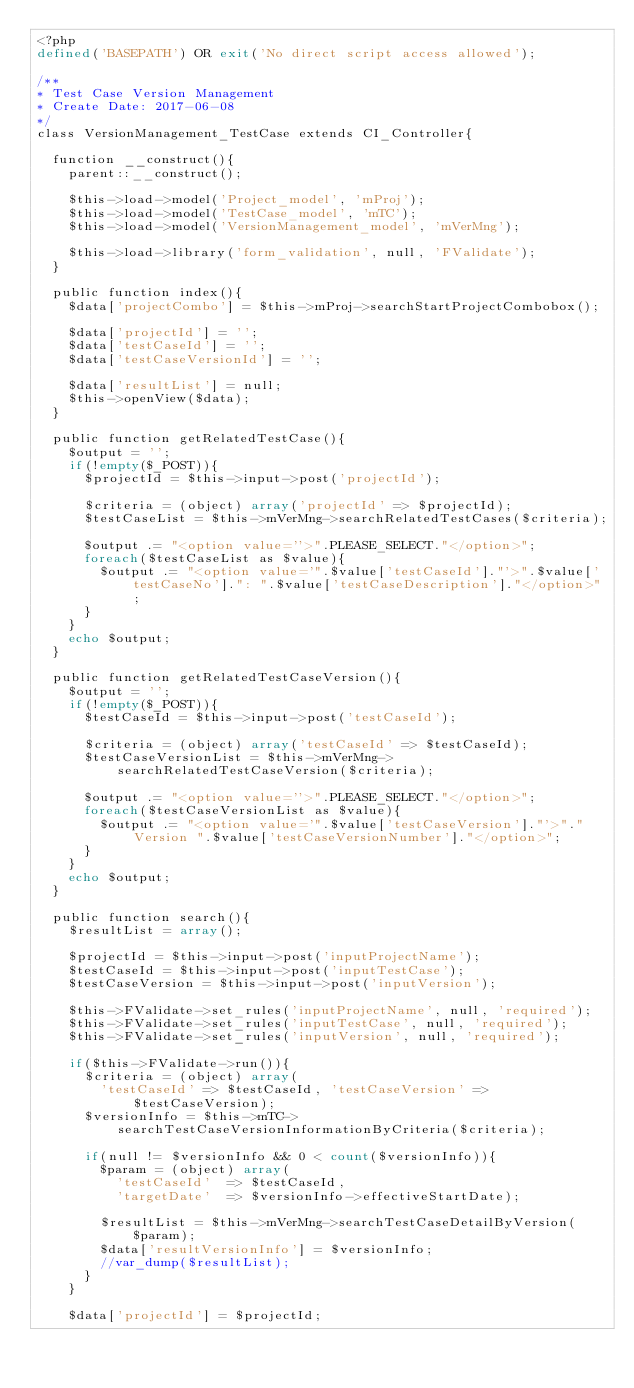<code> <loc_0><loc_0><loc_500><loc_500><_PHP_><?php 
defined('BASEPATH') OR exit('No direct script access allowed');

/**
* Test Case Version Management
* Create Date: 2017-06-08
*/
class VersionManagement_TestCase extends CI_Controller{
	
	function __construct(){
		parent::__construct();

		$this->load->model('Project_model', 'mProj');
		$this->load->model('TestCase_model', 'mTC');
		$this->load->model('VersionManagement_model', 'mVerMng');

		$this->load->library('form_validation', null, 'FValidate');
	}

	public function index(){
		$data['projectCombo'] = $this->mProj->searchStartProjectCombobox();

		$data['projectId'] = '';
		$data['testCaseId'] = '';
		$data['testCaseVersionId'] = '';

		$data['resultList'] = null;
		$this->openView($data);
	}

	public function getRelatedTestCase(){
		$output = '';
		if(!empty($_POST)){
			$projectId = $this->input->post('projectId');

			$criteria = (object) array('projectId' => $projectId);
			$testCaseList = $this->mVerMng->searchRelatedTestCases($criteria);

			$output .= "<option value=''>".PLEASE_SELECT."</option>";
			foreach($testCaseList as $value){
				$output .= "<option value='".$value['testCaseId']."'>".$value['testCaseNo'].": ".$value['testCaseDescription']."</option>";
			}
		}
		echo $output;
	}

	public function getRelatedTestCaseVersion(){
		$output = '';
		if(!empty($_POST)){
			$testCaseId = $this->input->post('testCaseId');

			$criteria = (object) array('testCaseId' => $testCaseId);
			$testCaseVersionList = $this->mVerMng->searchRelatedTestCaseVersion($criteria);

			$output .= "<option value=''>".PLEASE_SELECT."</option>";
			foreach($testCaseVersionList as $value){
				$output .= "<option value='".$value['testCaseVersion']."'>"."Version ".$value['testCaseVersionNumber']."</option>";
			}
		}
		echo $output;
	}

	public function search(){
		$resultList = array();

		$projectId = $this->input->post('inputProjectName');
		$testCaseId = $this->input->post('inputTestCase');
		$testCaseVersion = $this->input->post('inputVersion');

		$this->FValidate->set_rules('inputProjectName', null, 'required');
		$this->FValidate->set_rules('inputTestCase', null, 'required');
		$this->FValidate->set_rules('inputVersion', null, 'required');

		if($this->FValidate->run()){
			$criteria = (object) array(
				'testCaseId' => $testCaseId, 'testCaseVersion' => $testCaseVersion);
			$versionInfo = $this->mTC->searchTestCaseVersionInformationByCriteria($criteria);

			if(null != $versionInfo && 0 < count($versionInfo)){
				$param = (object) array(
					'testCaseId' 	=> $testCaseId,
					'targetDate' 	=> $versionInfo->effectiveStartDate);
				
				$resultList = $this->mVerMng->searchTestCaseDetailByVersion($param);
				$data['resultVersionInfo'] = $versionInfo;
				//var_dump($resultList);
			}
		}

		$data['projectId'] = $projectId;</code> 